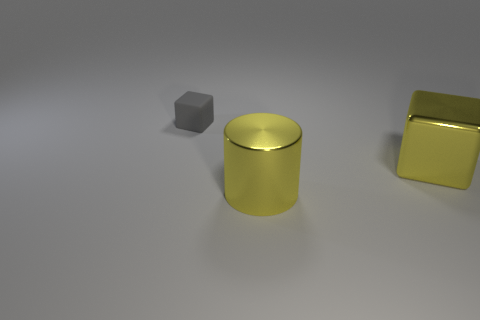Add 1 matte things. How many objects exist? 4 Subtract all blocks. How many objects are left? 1 Add 2 blue cubes. How many blue cubes exist? 2 Subtract 0 cyan blocks. How many objects are left? 3 Subtract all small gray matte blocks. Subtract all gray things. How many objects are left? 1 Add 2 yellow cubes. How many yellow cubes are left? 3 